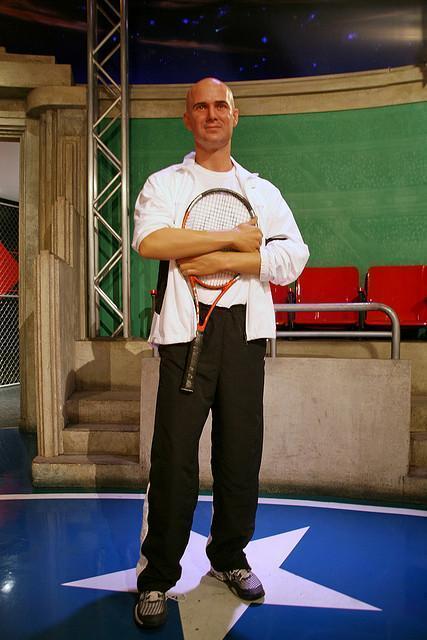What sports equipment is the man holding?
Indicate the correct choice and explain in the format: 'Answer: answer
Rationale: rationale.'
Options: Golf, hockey, tennis, cricket. Answer: tennis.
Rationale: A man stands on front of a green chalkboard hugging a tennis racket to his chest. 